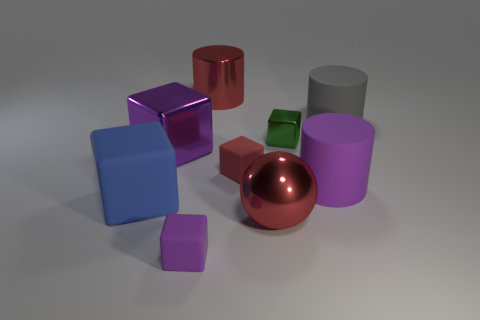There is a green object; is it the same size as the purple object to the right of the large red cylinder?
Keep it short and to the point. No. How many other things are there of the same size as the green metallic object?
Your answer should be compact. 2. How many other things are there of the same color as the large metallic cylinder?
Provide a succinct answer. 2. Are there any other things that have the same size as the purple cylinder?
Keep it short and to the point. Yes. What number of other things are the same shape as the tiny red rubber object?
Provide a short and direct response. 4. Does the blue rubber thing have the same size as the purple rubber cube?
Offer a very short reply. No. Are any big blue matte blocks visible?
Offer a very short reply. Yes. Is there anything else that is the same material as the ball?
Ensure brevity in your answer.  Yes. Is there a blue block made of the same material as the large blue object?
Make the answer very short. No. There is a sphere that is the same size as the blue thing; what is it made of?
Your response must be concise. Metal. 